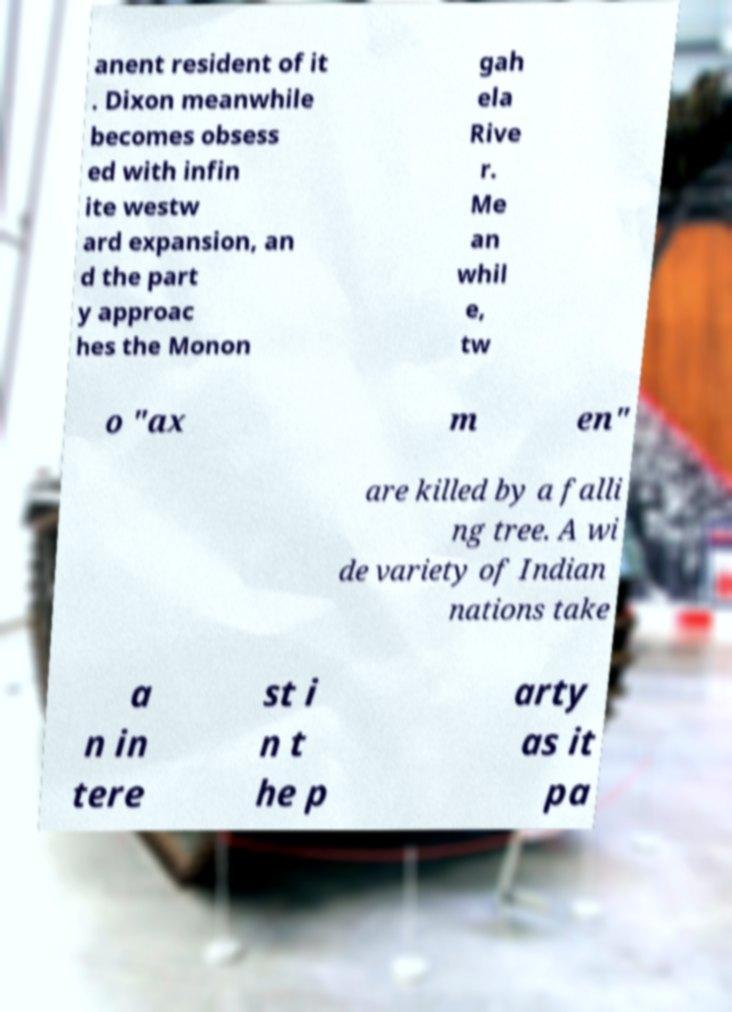There's text embedded in this image that I need extracted. Can you transcribe it verbatim? anent resident of it . Dixon meanwhile becomes obsess ed with infin ite westw ard expansion, an d the part y approac hes the Monon gah ela Rive r. Me an whil e, tw o "ax m en" are killed by a falli ng tree. A wi de variety of Indian nations take a n in tere st i n t he p arty as it pa 